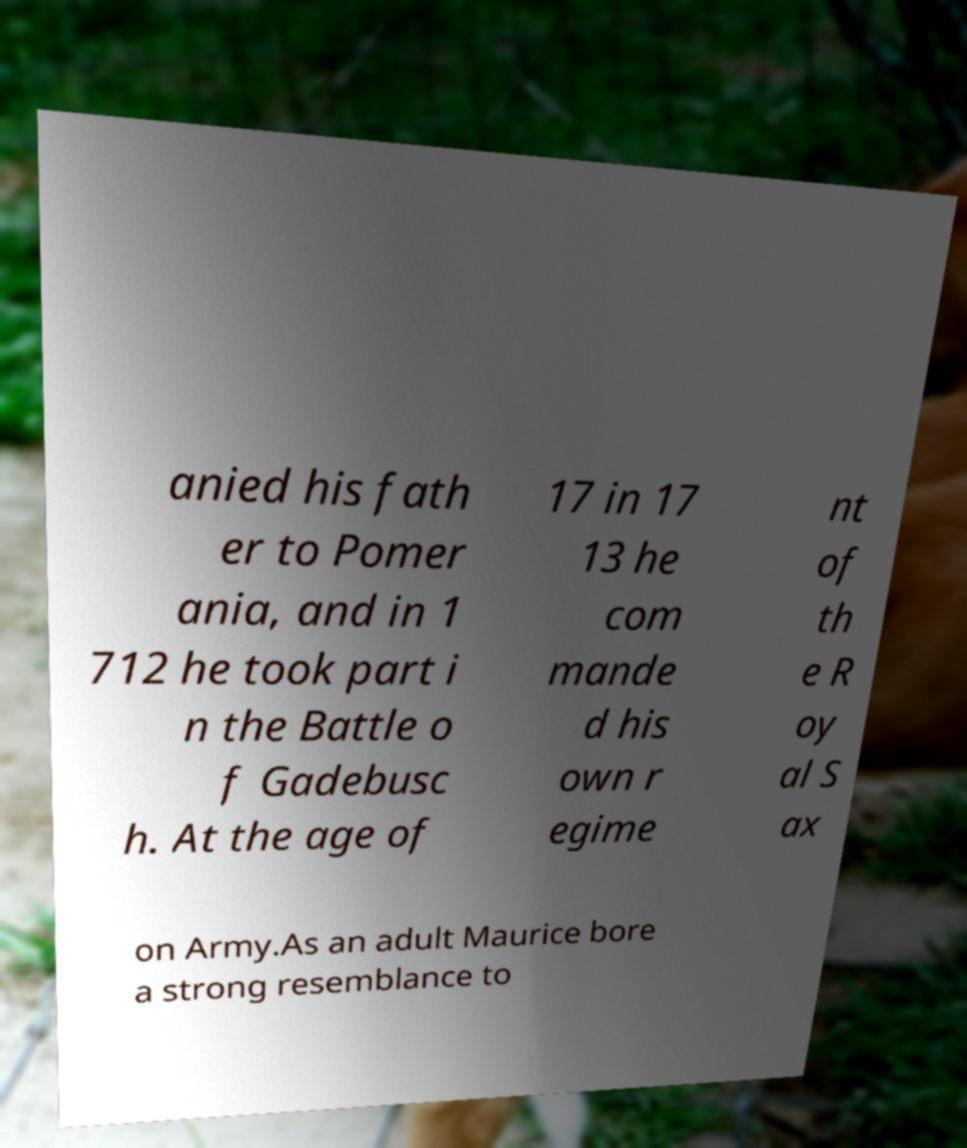I need the written content from this picture converted into text. Can you do that? anied his fath er to Pomer ania, and in 1 712 he took part i n the Battle o f Gadebusc h. At the age of 17 in 17 13 he com mande d his own r egime nt of th e R oy al S ax on Army.As an adult Maurice bore a strong resemblance to 